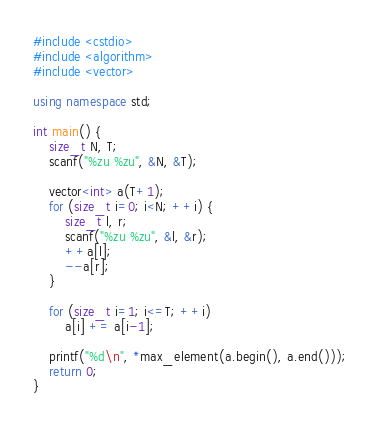Convert code to text. <code><loc_0><loc_0><loc_500><loc_500><_C++_>#include <cstdio>
#include <algorithm>
#include <vector>

using namespace std;

int main() {
    size_t N, T;
    scanf("%zu %zu", &N, &T);

    vector<int> a(T+1);
    for (size_t i=0; i<N; ++i) {
        size_t l, r;
        scanf("%zu %zu", &l, &r);
        ++a[l];
        --a[r];
    }

    for (size_t i=1; i<=T; ++i)
        a[i] += a[i-1];

    printf("%d\n", *max_element(a.begin(), a.end()));
    return 0;
}</code> 